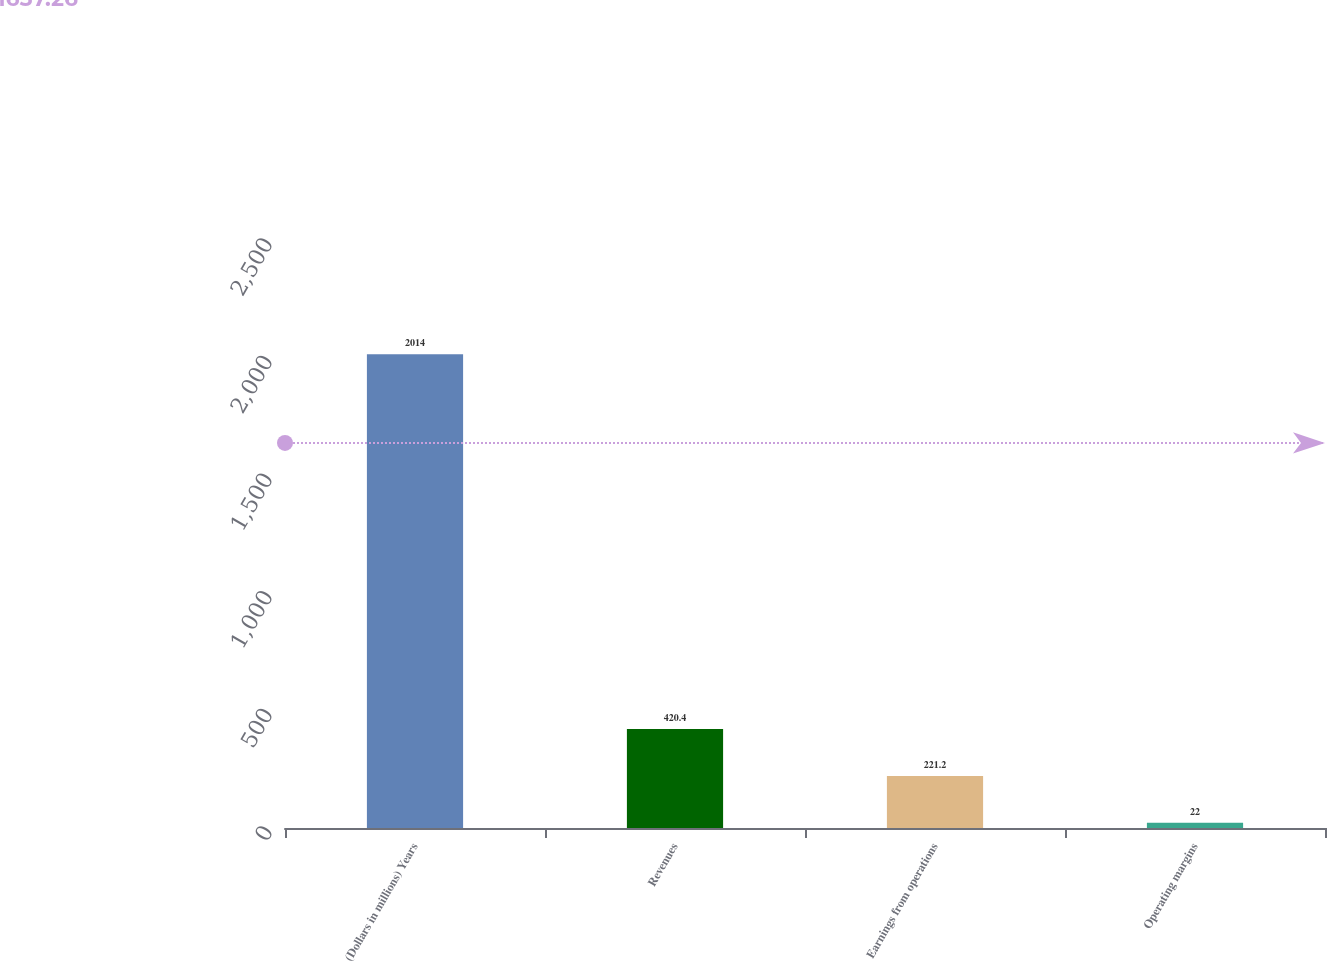Convert chart. <chart><loc_0><loc_0><loc_500><loc_500><bar_chart><fcel>(Dollars in millions) Years<fcel>Revenues<fcel>Earnings from operations<fcel>Operating margins<nl><fcel>2014<fcel>420.4<fcel>221.2<fcel>22<nl></chart> 